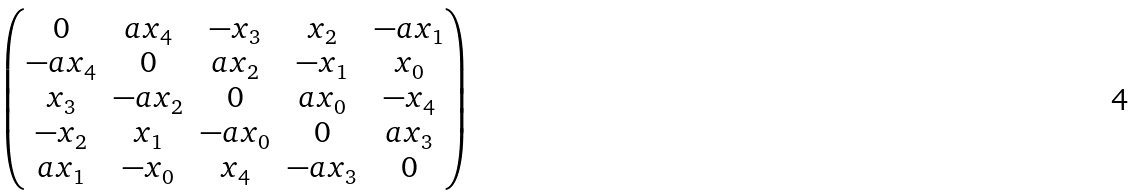<formula> <loc_0><loc_0><loc_500><loc_500>\begin{pmatrix} 0 & a x _ { 4 } & - x _ { 3 } & x _ { 2 } & - a x _ { 1 } \\ - a x _ { 4 } & 0 & a x _ { 2 } & - x _ { 1 } & x _ { 0 } \\ x _ { 3 } & - a x _ { 2 } & 0 & a x _ { 0 } & - x _ { 4 } \\ - x _ { 2 } & x _ { 1 } & - a x _ { 0 } & 0 & a x _ { 3 } \\ a x _ { 1 } & - x _ { 0 } & x _ { 4 } & - a x _ { 3 } & 0 \end{pmatrix}</formula> 